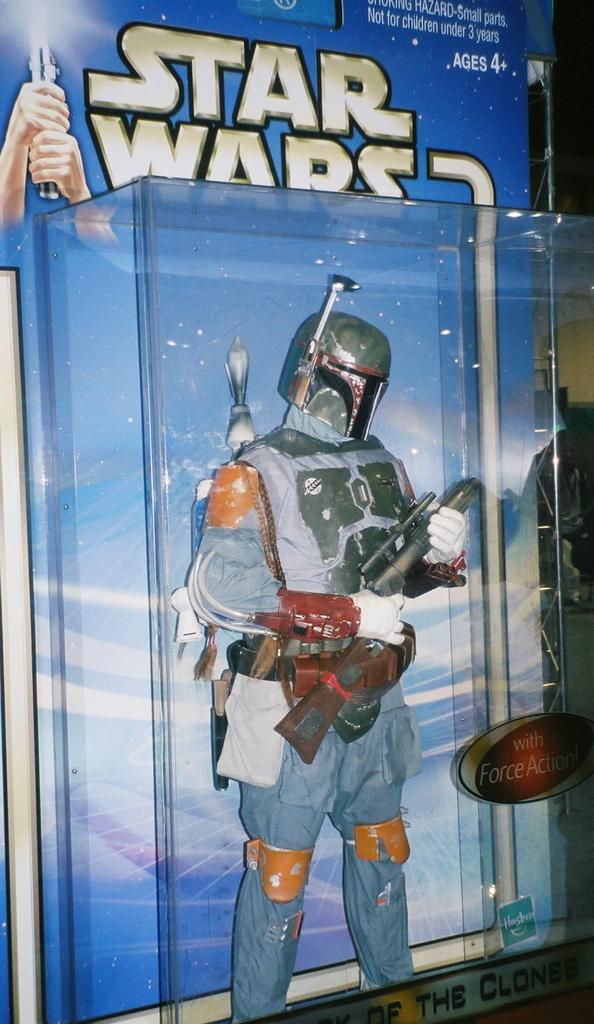<image>
Offer a succinct explanation of the picture presented. A Star Wars action figure that is for ages 4 and up. 